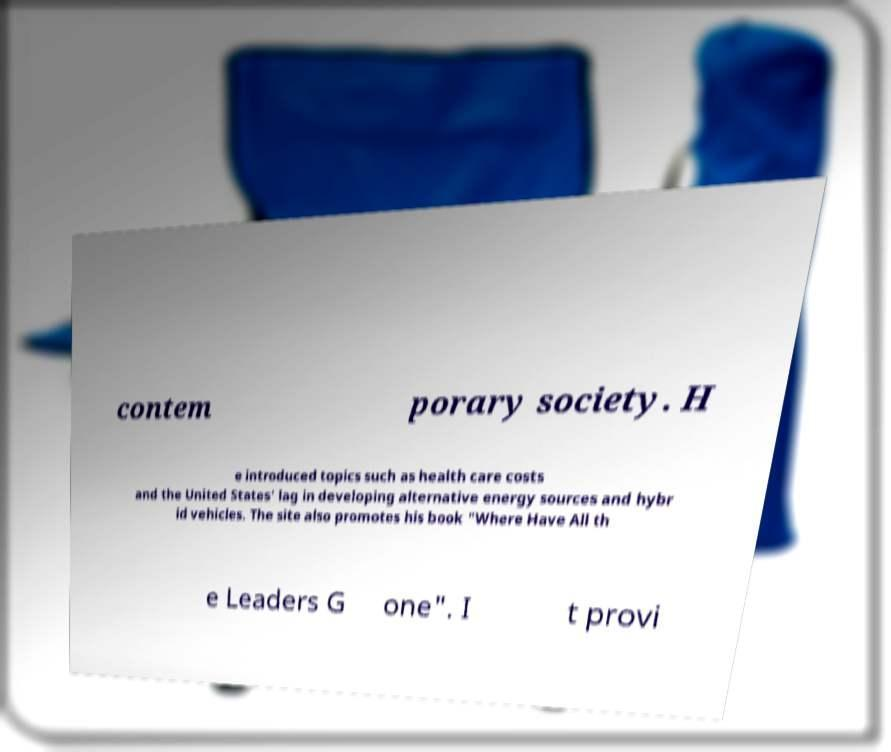Please read and relay the text visible in this image. What does it say? contem porary society. H e introduced topics such as health care costs and the United States' lag in developing alternative energy sources and hybr id vehicles. The site also promotes his book "Where Have All th e Leaders G one". I t provi 